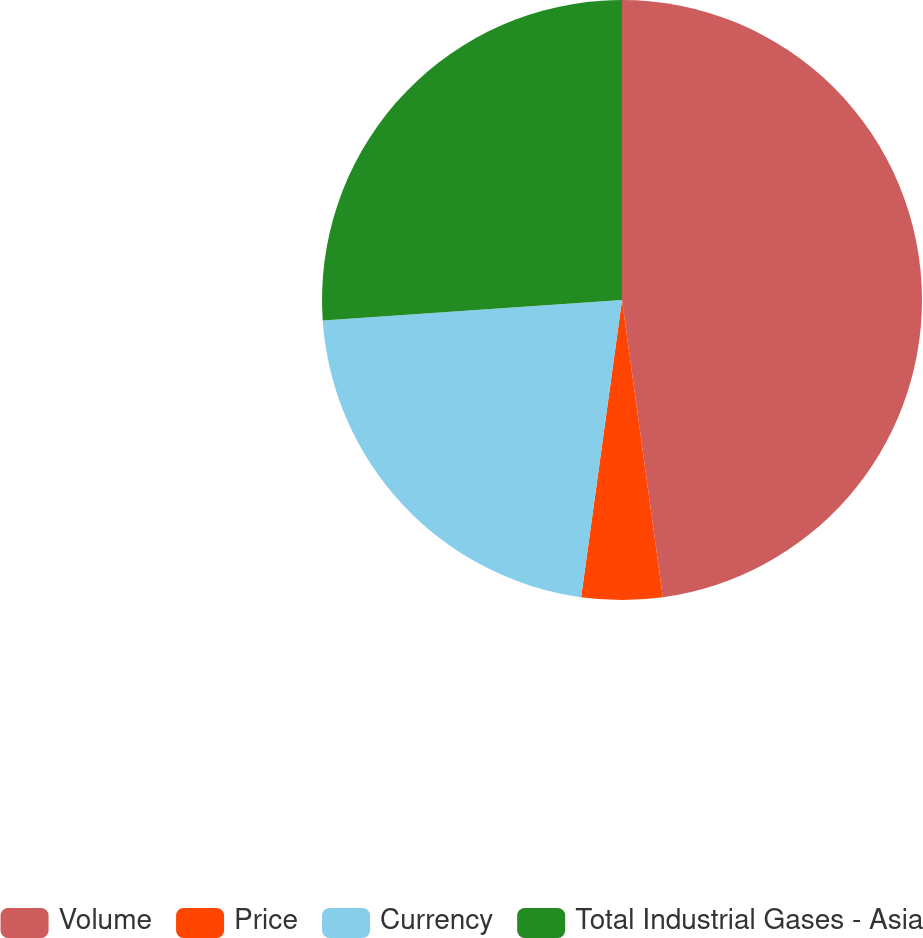Convert chart. <chart><loc_0><loc_0><loc_500><loc_500><pie_chart><fcel>Volume<fcel>Price<fcel>Currency<fcel>Total Industrial Gases - Asia<nl><fcel>47.83%<fcel>4.35%<fcel>21.74%<fcel>26.09%<nl></chart> 